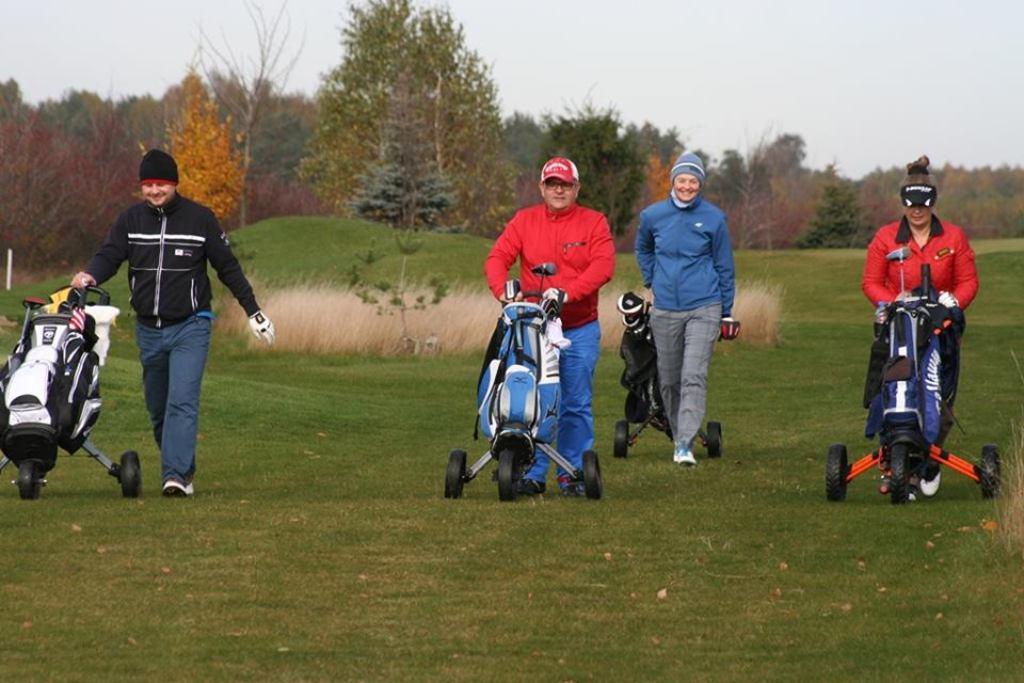Could you give a brief overview of what you see in this image? In this picture I can see few persons are pushing the carts, in the background there are trees. At the top there is the sky. 